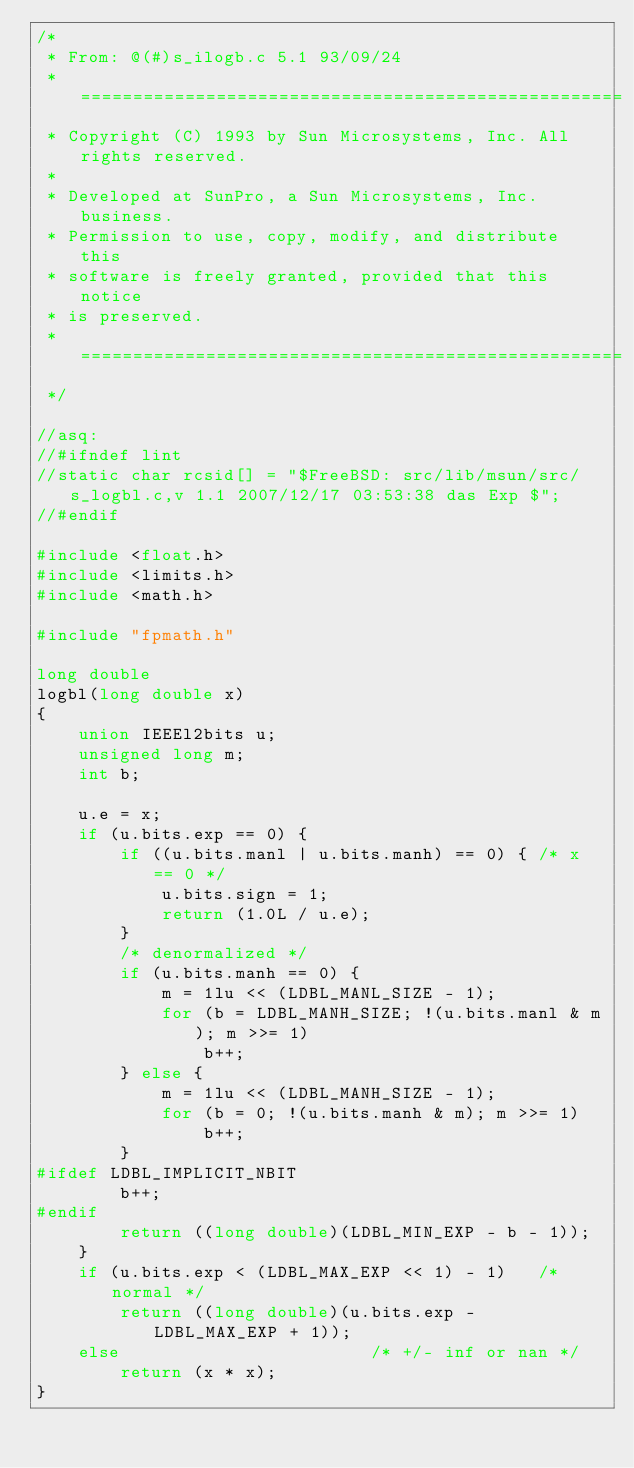Convert code to text. <code><loc_0><loc_0><loc_500><loc_500><_C_>/*
 * From: @(#)s_ilogb.c 5.1 93/09/24
 * ====================================================
 * Copyright (C) 1993 by Sun Microsystems, Inc. All rights reserved.
 *
 * Developed at SunPro, a Sun Microsystems, Inc. business.
 * Permission to use, copy, modify, and distribute this
 * software is freely granted, provided that this notice
 * is preserved.
 * ====================================================
 */

//asq:
//#ifndef lint
//static char rcsid[] = "$FreeBSD: src/lib/msun/src/s_logbl.c,v 1.1 2007/12/17 03:53:38 das Exp $";
//#endif

#include <float.h>
#include <limits.h>
#include <math.h>

#include "fpmath.h"

long double
logbl(long double x)
{
	union IEEEl2bits u;
	unsigned long m;
	int b;

	u.e = x;
	if (u.bits.exp == 0) {
		if ((u.bits.manl | u.bits.manh) == 0) {	/* x == 0 */
			u.bits.sign = 1;
			return (1.0L / u.e);
		}
		/* denormalized */
		if (u.bits.manh == 0) {
			m = 1lu << (LDBL_MANL_SIZE - 1);
			for (b = LDBL_MANH_SIZE; !(u.bits.manl & m); m >>= 1)
				b++;
		} else {
			m = 1lu << (LDBL_MANH_SIZE - 1);
			for (b = 0; !(u.bits.manh & m); m >>= 1)
				b++;
		}
#ifdef LDBL_IMPLICIT_NBIT
		b++;
#endif
		return ((long double)(LDBL_MIN_EXP - b - 1));
	}
	if (u.bits.exp < (LDBL_MAX_EXP << 1) - 1)	/* normal */
		return ((long double)(u.bits.exp - LDBL_MAX_EXP + 1));
	else						/* +/- inf or nan */
		return (x * x);
}
</code> 